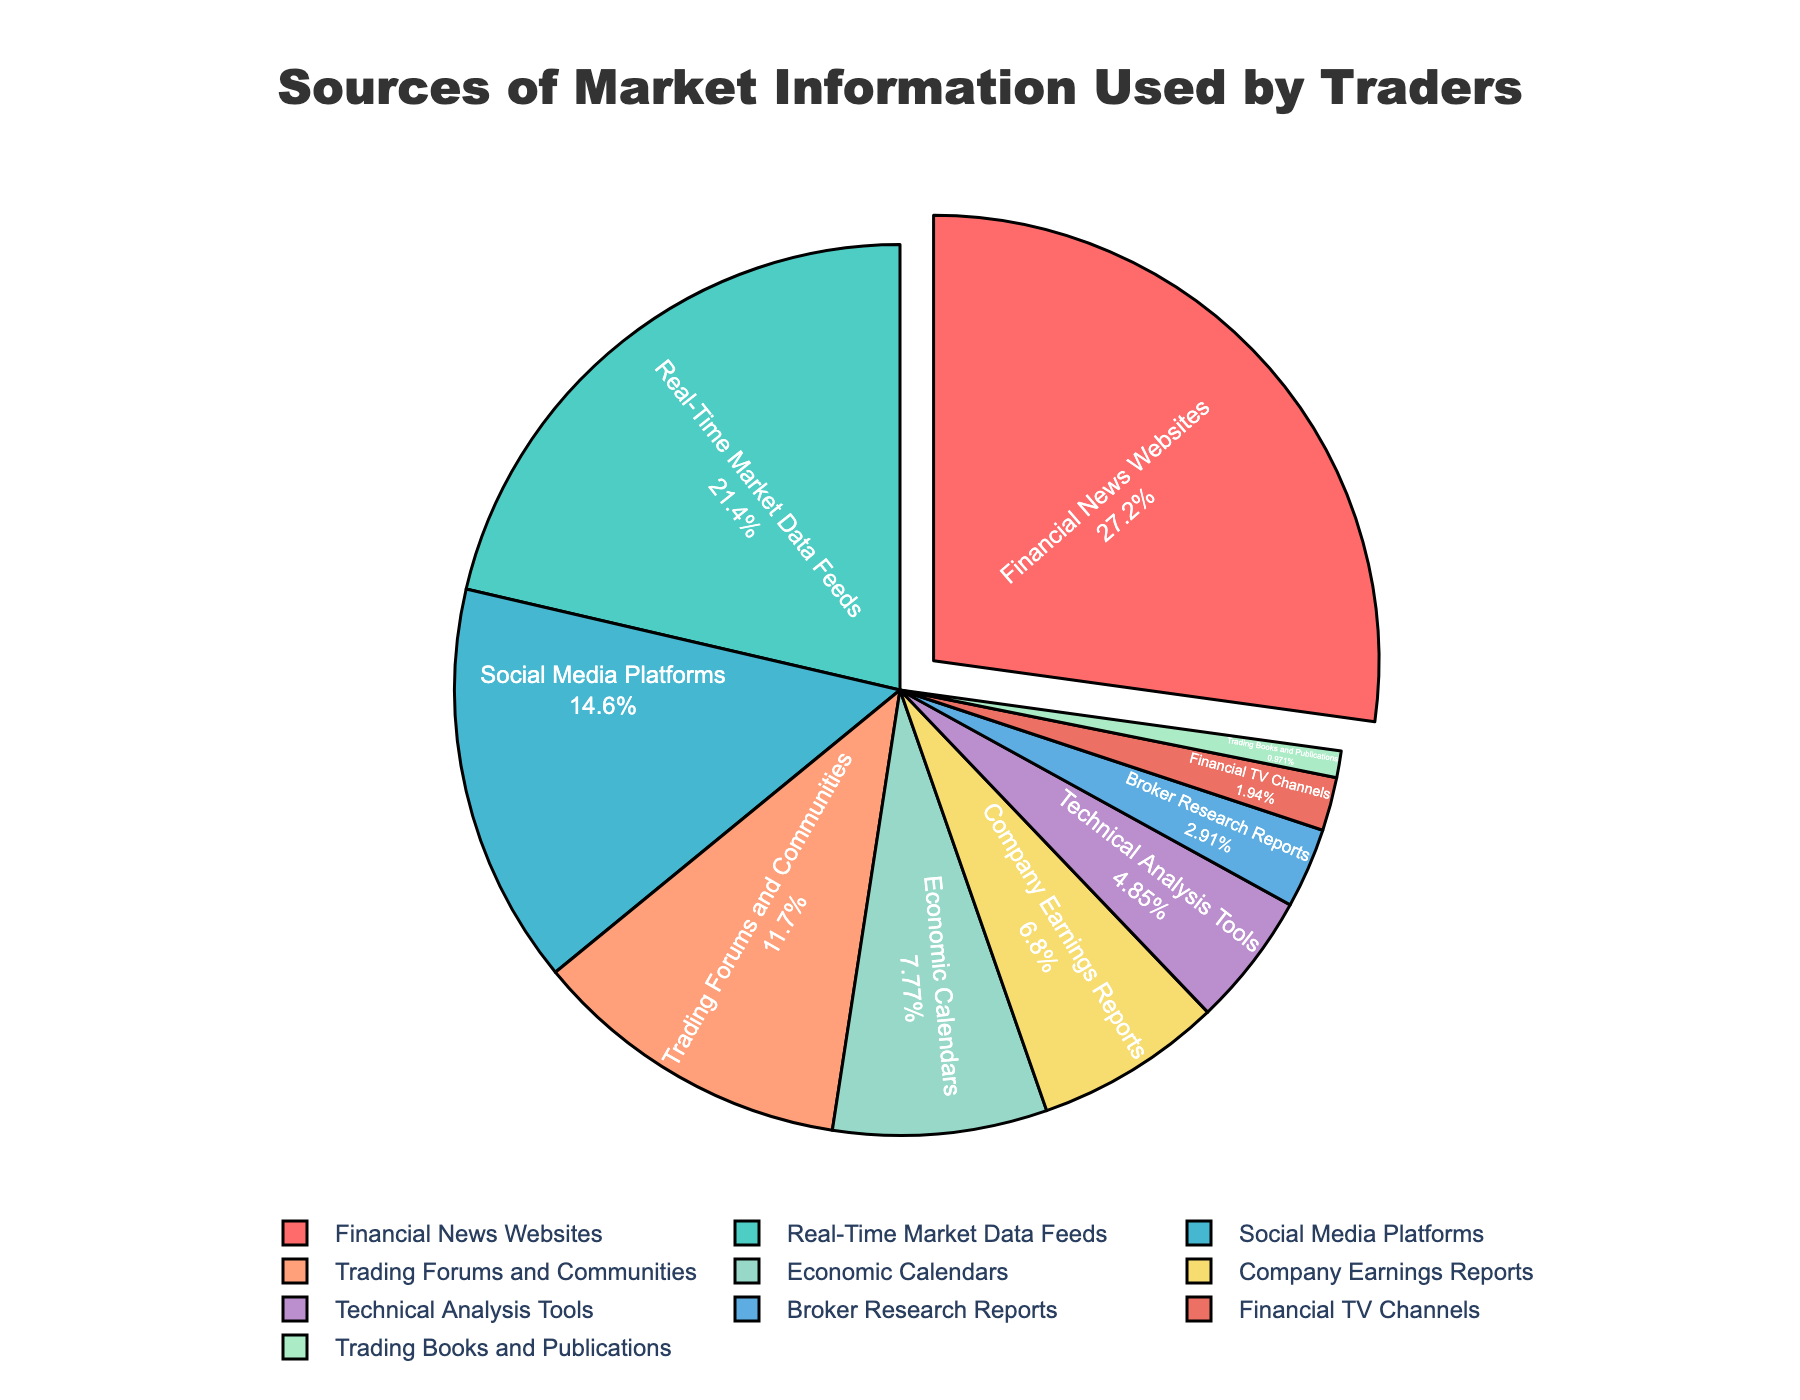What is the most frequently used source of market information by traders? Financial News Websites hold the highest percentage among the provided categories.
Answer: Financial News Websites How do the combined percentages of Real-Time Market Data Feeds and Social Media Platforms compare to Financial News Websites? Real-Time Market Data Feeds are 22% and Social Media Platforms are 15%. Combined, their percentage is 22 + 15 = 37%, which is higher than the 28% for Financial News Websites.
Answer: 37% is higher than 28% Which category has a slightly higher usage: Company Earnings Reports or Economic Calendars? Company Earnings Reports have 7% while Economic Calendars have 8%. Checking the percentages, Economic Calendars have a slightly higher usage.
Answer: Economic Calendars What is the total percentage of traders using Trading Forums and Communities, and Technical Analysis Tools combined? Trading Forums and Communities have 12% and Technical Analysis Tools have 5%. Adding them gives 12 + 5 = 17%.
Answer: 17% Which sources of market information are used by fewer than 5% of traders? Based on the percentages, Broker Research Reports (3%), Financial TV Channels (2%), and Trading Books and Publications (1%) fall under this category.
Answer: Broker Research Reports, Financial TV Channels, Trading Books and Publications By how much does the usage of Trading Forums and Communities exceed the usage of Economic Calendars? Trading Forums and Communities are at 12% while Economic Calendars are at 8%. Subtracting these gives 12 - 8 = 4%.
Answer: 4% What colors represent Financial News Websites and Real-Time Market Data Feeds in the pie chart? Financial News Websites are represented by red and Real-Time Market Data Feeds are represented by green.
Answer: Red for Financial News Websites, Green for Real-Time Market Data Feeds Is the percentage of traders using Social Media Platforms higher than that of those using Company Earnings Reports and Technical Analysis Tools combined? Social Media Platforms have 15%. Company Earnings Reports have 7% and Technical Analysis Tools have 5%, combining to 7 + 5 = 12%. Therefore, 15% is higher than 12%.
Answer: Yes Which category has the lowest percentage of users, and what is that percentage? Trading Books and Publications have the lowest percentage at 1%.
Answer: Trading Books and Publications, 1% What is the combined percentage of the top three sources of market information used by traders? The top three sources are Financial News Websites (28%), Real-Time Market Data Feeds (22%), and Social Media Platforms (15%). Their combined percentage is 28 + 22 + 15 = 65%.
Answer: 65% 